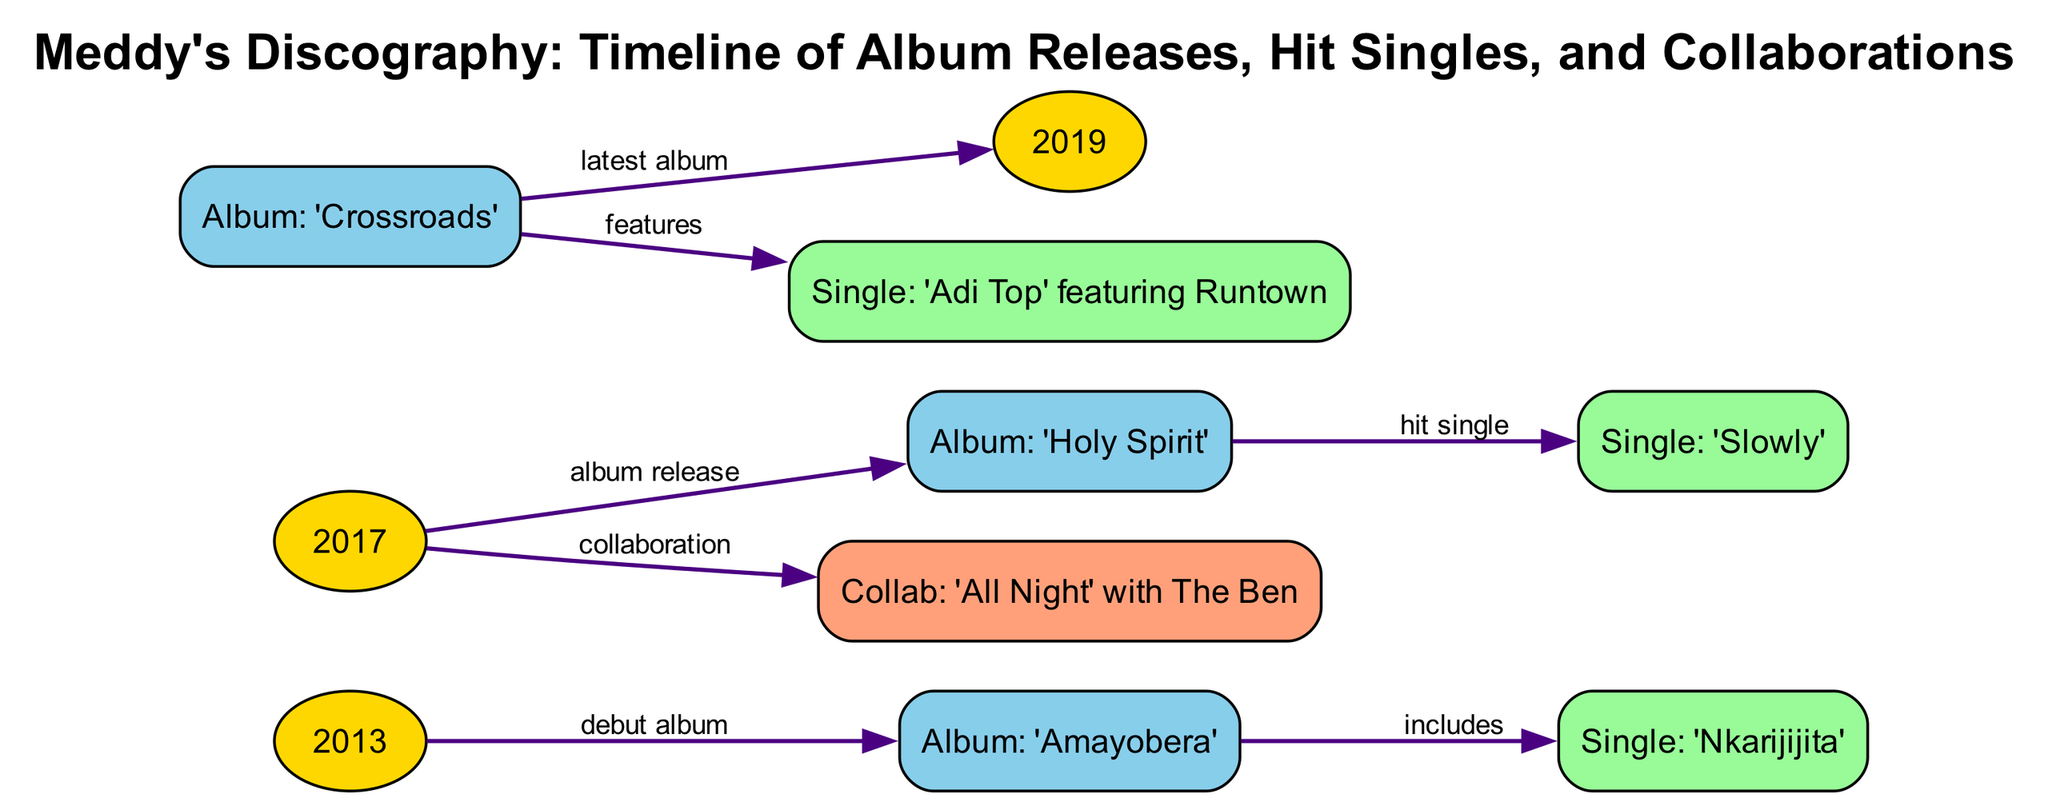What year was Meddy's debut album released? According to the diagram, the debut album 'Amayobera' is connected to the year 2013, indicating that it was released in that year.
Answer: 2013 How many albums has Meddy released as of 2019? The diagram shows three album nodes: 'Amayobera' (2013), 'Holy Spirit' (2017), and 'Crossroads' (2019), totaling three albums.
Answer: 3 What is the name of the single released with 'Holy Spirit'? The diagram indicates that the album 'Holy Spirit' (2017) includes the hit single 'Slowly', so the name of the single is 'Slowly'.
Answer: Slowly Which single features Runtown? The edge from the album 'Crossroads' points to the single 'Adi Top', which is specified as featuring Runtown in the label. Therefore, the single that features Runtown is 'Adi Top'.
Answer: Adi Top In what year was the collaboration 'All Night' with The Ben released? The diagram shows that the collaboration 'All Night' with The Ben is connected to the year 2017, indicating its release year.
Answer: 2017 What is the relationship between 'Amayobera' and 'Nkarijijita'? The diagram illustrates that 'Nkarijijita' is a single that is included in the album 'Amayobera', showing a direct relationship where the single belongs to that album.
Answer: includes Which album is noted as the latest album in the diagram? The diagram specifies that 'Crossroads' is connected to the year 2019 and is labeled as the latest album, thus it is the most recent album released by Meddy.
Answer: Crossroads How many hit singles are presented in the diagram? The diagram indicates two hit singles: 'Slowly' from 'Holy Spirit' and 'Adi Top' from 'Crossroads', leading to the conclusion that there are two hit singles displayed.
Answer: 2 What is the type of the node labeled '2017'? The year 2017 is categorized as a type 'year' node in the diagram, which is specified in its type designation.
Answer: year 